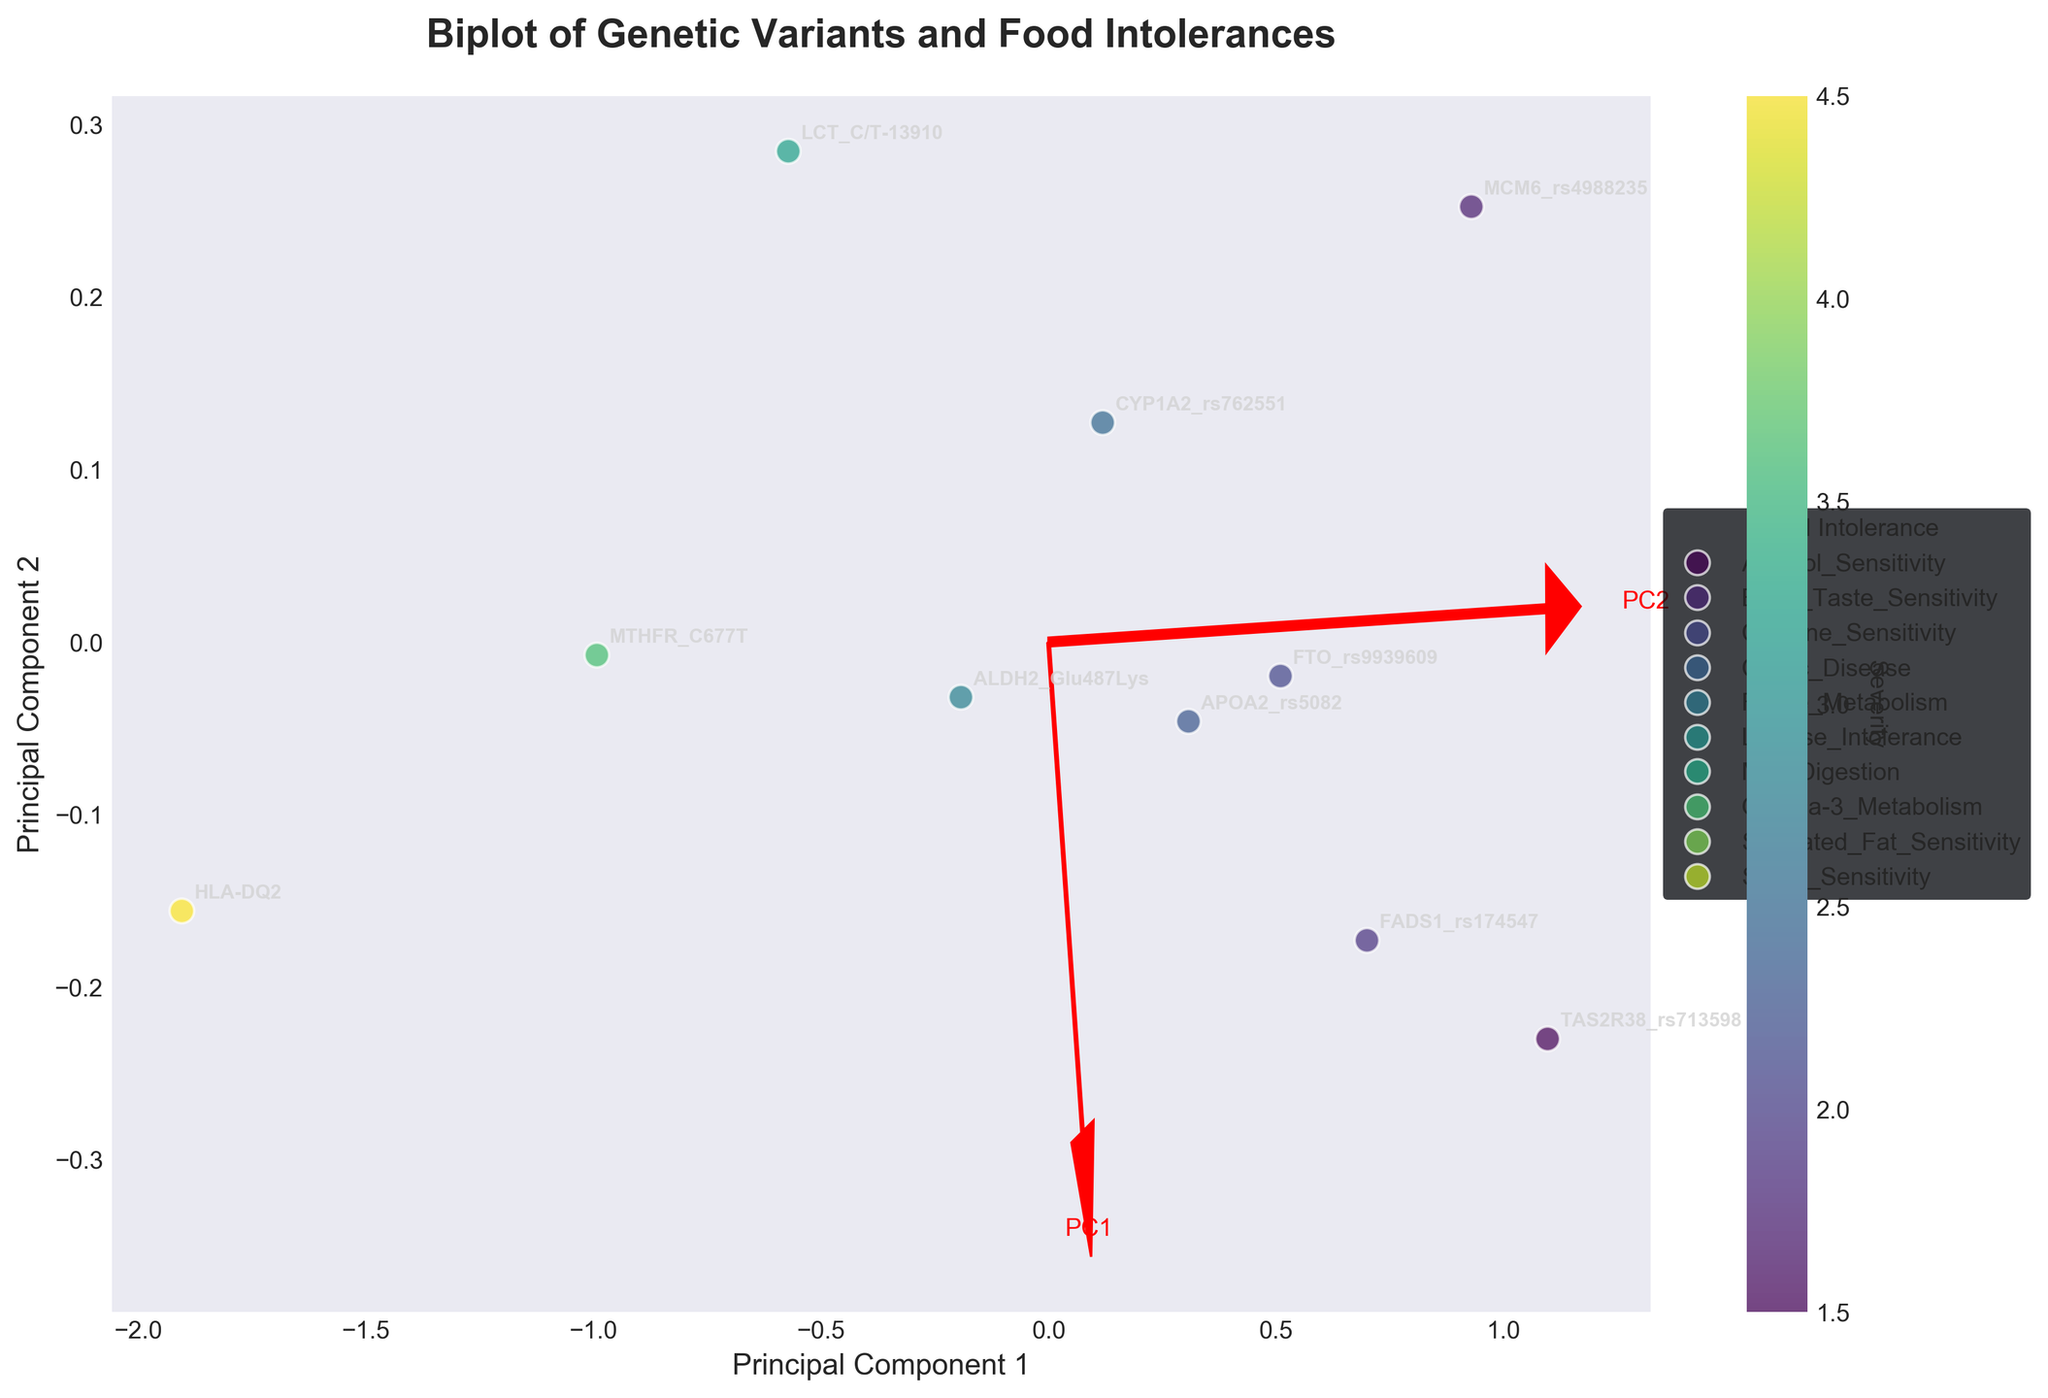What are the axes labeled in the figure? The axes in the figure represent the principal components derived from the data, specifically labeled as "Principal Component 1" and "Principal Component 2".
Answer: Principal Component 1 and Principal Component 2 How many unique food intolerances are represented in the figure? By looking at the legend on the right side of the figure, which lists all the unique food intolerances, we can count them. There are 10 unique food intolerances as per the legend.
Answer: 10 Which genetic variant is located furthest to the right on the Principal Component 1 axis? By examining the distribution of data points along the Principal Component 1 axis, MCM6_rs4988235 is the genetic variant farthest to the right.
Answer: MCM6_rs4988235 What is the title of the figure? The title of the figure is displayed at the top and it reads "Biplot of Genetic Variants and Food Intolerances".
Answer: Biplot of Genetic Variants and Food Intolerances Which food intolerance has the highest severity according to the color bar? According to the color bar, the highest severity is found in Celiac Disease (HLA-DQ2), as it is colored in the darkest shade.
Answer: Celiac Disease Which genetic variant has the lowest prevalence and where is it located on Principal Component 1 and Principal Component 2 axes? To find the genetic variant with the lowest prevalence, we refer to the original data. HLA-DQ2 has the lowest prevalence of 0.12. In the figure, it is located on the negative side of Principal Component 1 and slightly positive on Principal Component 2.
Answer: HLA-DQ2 Between LCT_C/T-13910 and FTO_rs9939609, which one has higher severity and how are they positioned in the plot? LCT_C/T-13910 has a higher severity (3.2) compared to FTO_rs9939609 (2.1). In the plot, LCT_C/T-13910 is located towards the positive side of Principal Component 2, while FTO_rs9939609 is closer to the negative side of Principal Component 2.
Answer: LCT_C/T-13910; LCT_C/T-13910 is higher on PC2, FTO_rs9939609 is lower on PC2 Which vectors (eigenvectors) are plotted in the figure and how are they represented? The figure contains two eigenvectors indicating the directions of the principal components. They are represented by red arrows originating from the origin (0,0) and labeled as "PC1" and "PC2".
Answer: PC1 and PC2 with red arrows What color represents the severity level of 4.5 on the color bar? The color map (viridis) on the figure shows a gradient, with darker shades indicating higher severity. A severity level of 4.5 corresponds to a dark greenish color.
Answer: Dark greenish 